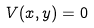<formula> <loc_0><loc_0><loc_500><loc_500>V ( x , y ) = 0</formula> 